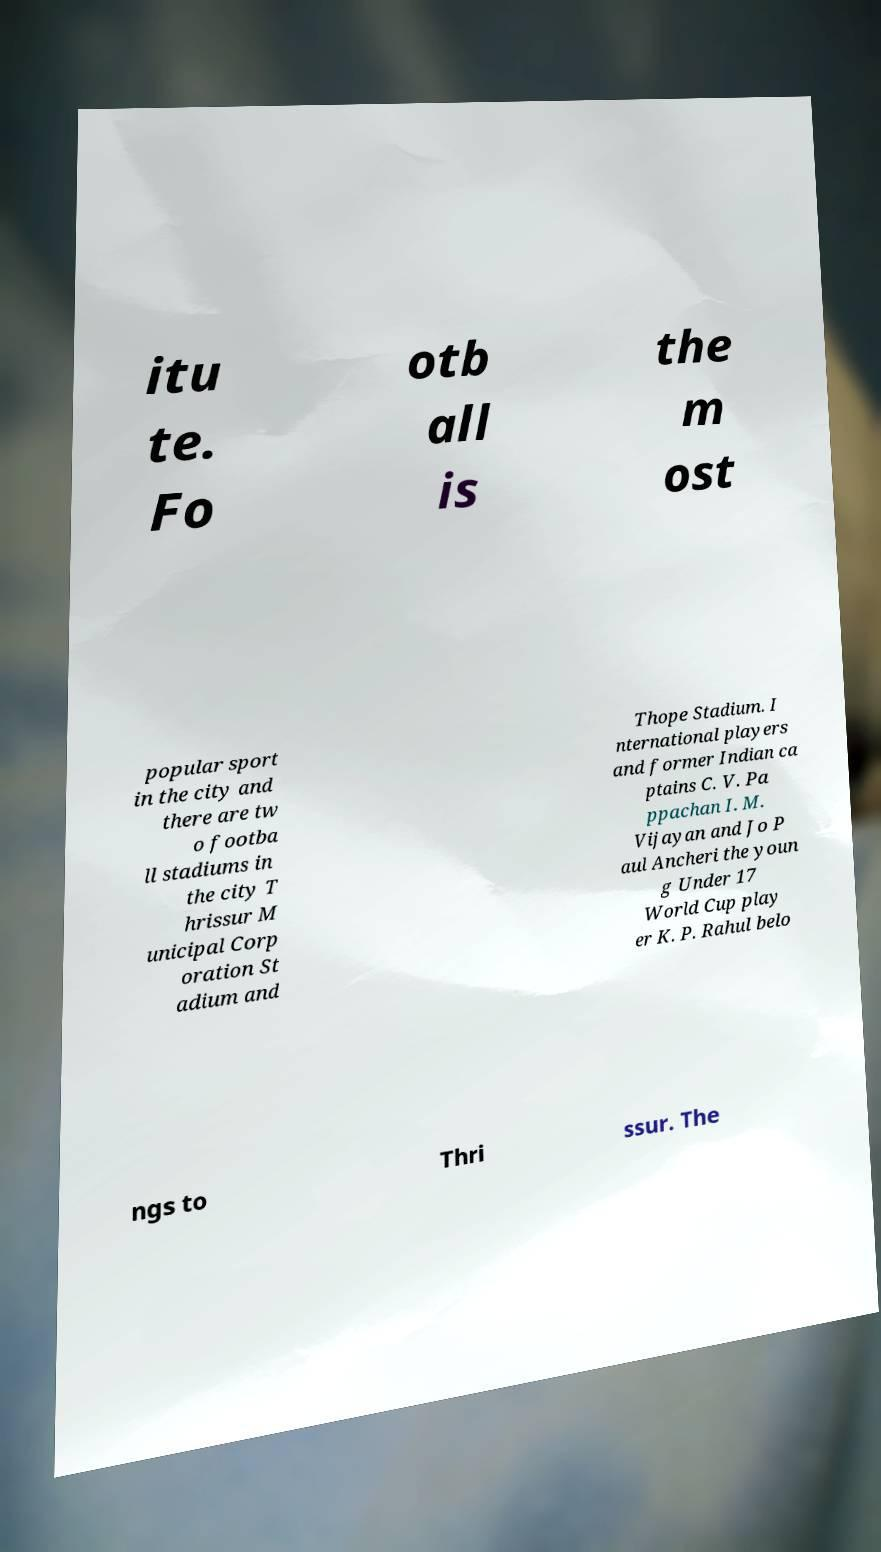There's text embedded in this image that I need extracted. Can you transcribe it verbatim? itu te. Fo otb all is the m ost popular sport in the city and there are tw o footba ll stadiums in the city T hrissur M unicipal Corp oration St adium and Thope Stadium. I nternational players and former Indian ca ptains C. V. Pa ppachan I. M. Vijayan and Jo P aul Ancheri the youn g Under 17 World Cup play er K. P. Rahul belo ngs to Thri ssur. The 